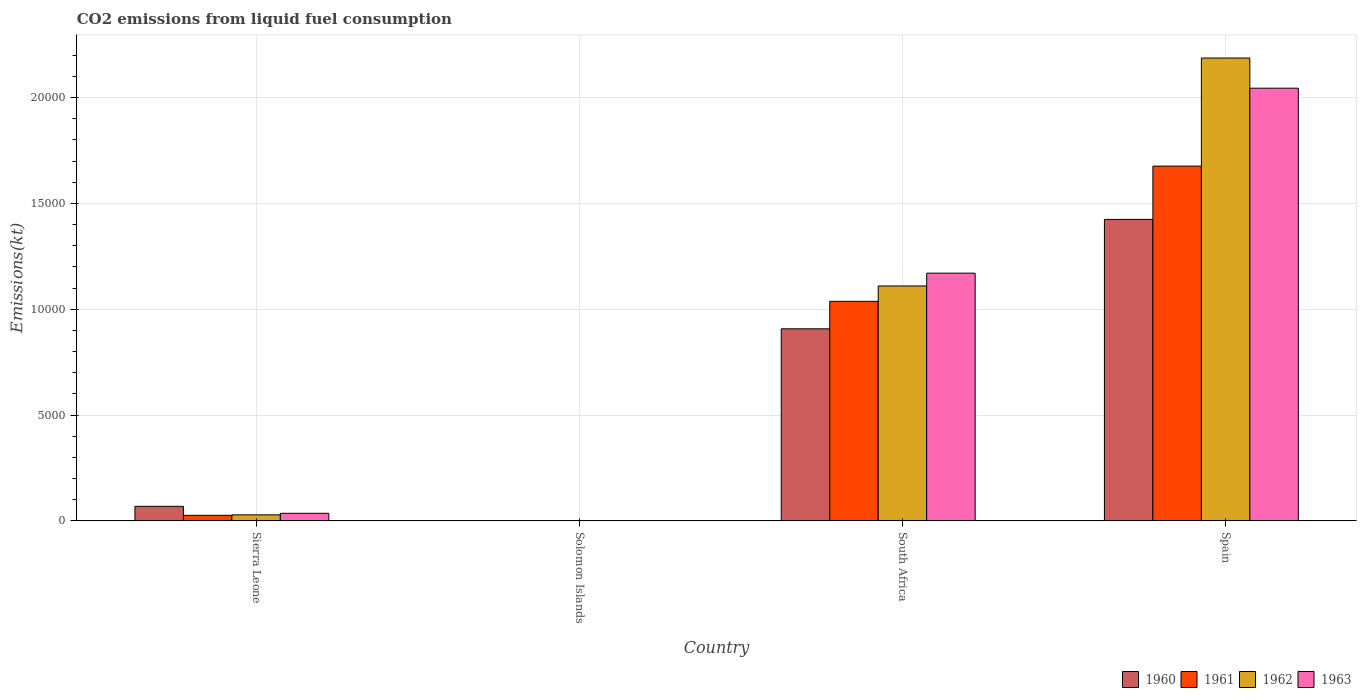Are the number of bars per tick equal to the number of legend labels?
Offer a very short reply. Yes. Are the number of bars on each tick of the X-axis equal?
Your answer should be very brief. Yes. How many bars are there on the 2nd tick from the left?
Offer a very short reply. 4. In how many cases, is the number of bars for a given country not equal to the number of legend labels?
Offer a very short reply. 0. What is the amount of CO2 emitted in 1962 in South Africa?
Provide a succinct answer. 1.11e+04. Across all countries, what is the maximum amount of CO2 emitted in 1962?
Provide a short and direct response. 2.19e+04. Across all countries, what is the minimum amount of CO2 emitted in 1962?
Give a very brief answer. 14.67. In which country was the amount of CO2 emitted in 1960 maximum?
Your answer should be compact. Spain. In which country was the amount of CO2 emitted in 1961 minimum?
Keep it short and to the point. Solomon Islands. What is the total amount of CO2 emitted in 1960 in the graph?
Ensure brevity in your answer.  2.40e+04. What is the difference between the amount of CO2 emitted in 1961 in South Africa and that in Spain?
Your answer should be compact. -6391.58. What is the difference between the amount of CO2 emitted in 1960 in Solomon Islands and the amount of CO2 emitted in 1962 in Sierra Leone?
Your response must be concise. -271.36. What is the average amount of CO2 emitted in 1963 per country?
Your answer should be very brief. 8130.66. What is the difference between the amount of CO2 emitted of/in 1961 and amount of CO2 emitted of/in 1962 in South Africa?
Offer a terse response. -726.07. What is the ratio of the amount of CO2 emitted in 1962 in Sierra Leone to that in Spain?
Provide a short and direct response. 0.01. Is the amount of CO2 emitted in 1962 in Solomon Islands less than that in Spain?
Offer a very short reply. Yes. What is the difference between the highest and the second highest amount of CO2 emitted in 1962?
Your response must be concise. 2.16e+04. What is the difference between the highest and the lowest amount of CO2 emitted in 1961?
Your answer should be compact. 1.68e+04. What does the 1st bar from the right in South Africa represents?
Provide a short and direct response. 1963. Is it the case that in every country, the sum of the amount of CO2 emitted in 1963 and amount of CO2 emitted in 1960 is greater than the amount of CO2 emitted in 1961?
Ensure brevity in your answer.  Yes. What is the difference between two consecutive major ticks on the Y-axis?
Ensure brevity in your answer.  5000. Does the graph contain any zero values?
Provide a succinct answer. No. Where does the legend appear in the graph?
Keep it short and to the point. Bottom right. How many legend labels are there?
Make the answer very short. 4. What is the title of the graph?
Your answer should be compact. CO2 emissions from liquid fuel consumption. What is the label or title of the X-axis?
Provide a short and direct response. Country. What is the label or title of the Y-axis?
Offer a very short reply. Emissions(kt). What is the Emissions(kt) in 1960 in Sierra Leone?
Your answer should be compact. 685.73. What is the Emissions(kt) of 1961 in Sierra Leone?
Keep it short and to the point. 260.36. What is the Emissions(kt) in 1962 in Sierra Leone?
Ensure brevity in your answer.  282.36. What is the Emissions(kt) of 1963 in Sierra Leone?
Make the answer very short. 355.7. What is the Emissions(kt) of 1960 in Solomon Islands?
Make the answer very short. 11. What is the Emissions(kt) in 1961 in Solomon Islands?
Ensure brevity in your answer.  14.67. What is the Emissions(kt) in 1962 in Solomon Islands?
Keep it short and to the point. 14.67. What is the Emissions(kt) of 1963 in Solomon Islands?
Offer a very short reply. 14.67. What is the Emissions(kt) of 1960 in South Africa?
Provide a succinct answer. 9075.83. What is the Emissions(kt) of 1961 in South Africa?
Provide a succinct answer. 1.04e+04. What is the Emissions(kt) of 1962 in South Africa?
Your answer should be very brief. 1.11e+04. What is the Emissions(kt) of 1963 in South Africa?
Provide a succinct answer. 1.17e+04. What is the Emissions(kt) in 1960 in Spain?
Your response must be concise. 1.42e+04. What is the Emissions(kt) of 1961 in Spain?
Make the answer very short. 1.68e+04. What is the Emissions(kt) of 1962 in Spain?
Keep it short and to the point. 2.19e+04. What is the Emissions(kt) in 1963 in Spain?
Your answer should be very brief. 2.04e+04. Across all countries, what is the maximum Emissions(kt) of 1960?
Ensure brevity in your answer.  1.42e+04. Across all countries, what is the maximum Emissions(kt) of 1961?
Give a very brief answer. 1.68e+04. Across all countries, what is the maximum Emissions(kt) in 1962?
Your answer should be very brief. 2.19e+04. Across all countries, what is the maximum Emissions(kt) in 1963?
Offer a terse response. 2.04e+04. Across all countries, what is the minimum Emissions(kt) in 1960?
Your response must be concise. 11. Across all countries, what is the minimum Emissions(kt) in 1961?
Your answer should be very brief. 14.67. Across all countries, what is the minimum Emissions(kt) in 1962?
Your response must be concise. 14.67. Across all countries, what is the minimum Emissions(kt) of 1963?
Ensure brevity in your answer.  14.67. What is the total Emissions(kt) in 1960 in the graph?
Your answer should be very brief. 2.40e+04. What is the total Emissions(kt) of 1961 in the graph?
Offer a very short reply. 2.74e+04. What is the total Emissions(kt) of 1962 in the graph?
Keep it short and to the point. 3.33e+04. What is the total Emissions(kt) of 1963 in the graph?
Ensure brevity in your answer.  3.25e+04. What is the difference between the Emissions(kt) of 1960 in Sierra Leone and that in Solomon Islands?
Offer a very short reply. 674.73. What is the difference between the Emissions(kt) in 1961 in Sierra Leone and that in Solomon Islands?
Your response must be concise. 245.69. What is the difference between the Emissions(kt) of 1962 in Sierra Leone and that in Solomon Islands?
Provide a succinct answer. 267.69. What is the difference between the Emissions(kt) in 1963 in Sierra Leone and that in Solomon Islands?
Keep it short and to the point. 341.03. What is the difference between the Emissions(kt) of 1960 in Sierra Leone and that in South Africa?
Offer a terse response. -8390.1. What is the difference between the Emissions(kt) in 1961 in Sierra Leone and that in South Africa?
Provide a succinct answer. -1.01e+04. What is the difference between the Emissions(kt) in 1962 in Sierra Leone and that in South Africa?
Provide a succinct answer. -1.08e+04. What is the difference between the Emissions(kt) of 1963 in Sierra Leone and that in South Africa?
Offer a very short reply. -1.13e+04. What is the difference between the Emissions(kt) of 1960 in Sierra Leone and that in Spain?
Give a very brief answer. -1.36e+04. What is the difference between the Emissions(kt) in 1961 in Sierra Leone and that in Spain?
Ensure brevity in your answer.  -1.65e+04. What is the difference between the Emissions(kt) in 1962 in Sierra Leone and that in Spain?
Make the answer very short. -2.16e+04. What is the difference between the Emissions(kt) of 1963 in Sierra Leone and that in Spain?
Make the answer very short. -2.01e+04. What is the difference between the Emissions(kt) of 1960 in Solomon Islands and that in South Africa?
Offer a very short reply. -9064.82. What is the difference between the Emissions(kt) of 1961 in Solomon Islands and that in South Africa?
Keep it short and to the point. -1.04e+04. What is the difference between the Emissions(kt) in 1962 in Solomon Islands and that in South Africa?
Provide a short and direct response. -1.11e+04. What is the difference between the Emissions(kt) in 1963 in Solomon Islands and that in South Africa?
Give a very brief answer. -1.17e+04. What is the difference between the Emissions(kt) of 1960 in Solomon Islands and that in Spain?
Make the answer very short. -1.42e+04. What is the difference between the Emissions(kt) of 1961 in Solomon Islands and that in Spain?
Ensure brevity in your answer.  -1.68e+04. What is the difference between the Emissions(kt) in 1962 in Solomon Islands and that in Spain?
Offer a terse response. -2.19e+04. What is the difference between the Emissions(kt) of 1963 in Solomon Islands and that in Spain?
Provide a short and direct response. -2.04e+04. What is the difference between the Emissions(kt) in 1960 in South Africa and that in Spain?
Your answer should be very brief. -5170.47. What is the difference between the Emissions(kt) in 1961 in South Africa and that in Spain?
Your answer should be compact. -6391.58. What is the difference between the Emissions(kt) in 1962 in South Africa and that in Spain?
Keep it short and to the point. -1.08e+04. What is the difference between the Emissions(kt) of 1963 in South Africa and that in Spain?
Offer a terse response. -8742.13. What is the difference between the Emissions(kt) of 1960 in Sierra Leone and the Emissions(kt) of 1961 in Solomon Islands?
Make the answer very short. 671.06. What is the difference between the Emissions(kt) of 1960 in Sierra Leone and the Emissions(kt) of 1962 in Solomon Islands?
Provide a succinct answer. 671.06. What is the difference between the Emissions(kt) of 1960 in Sierra Leone and the Emissions(kt) of 1963 in Solomon Islands?
Offer a terse response. 671.06. What is the difference between the Emissions(kt) of 1961 in Sierra Leone and the Emissions(kt) of 1962 in Solomon Islands?
Your response must be concise. 245.69. What is the difference between the Emissions(kt) of 1961 in Sierra Leone and the Emissions(kt) of 1963 in Solomon Islands?
Your answer should be very brief. 245.69. What is the difference between the Emissions(kt) of 1962 in Sierra Leone and the Emissions(kt) of 1963 in Solomon Islands?
Provide a succinct answer. 267.69. What is the difference between the Emissions(kt) in 1960 in Sierra Leone and the Emissions(kt) in 1961 in South Africa?
Your response must be concise. -9688.21. What is the difference between the Emissions(kt) of 1960 in Sierra Leone and the Emissions(kt) of 1962 in South Africa?
Keep it short and to the point. -1.04e+04. What is the difference between the Emissions(kt) of 1960 in Sierra Leone and the Emissions(kt) of 1963 in South Africa?
Give a very brief answer. -1.10e+04. What is the difference between the Emissions(kt) in 1961 in Sierra Leone and the Emissions(kt) in 1962 in South Africa?
Your answer should be very brief. -1.08e+04. What is the difference between the Emissions(kt) in 1961 in Sierra Leone and the Emissions(kt) in 1963 in South Africa?
Offer a terse response. -1.14e+04. What is the difference between the Emissions(kt) of 1962 in Sierra Leone and the Emissions(kt) of 1963 in South Africa?
Offer a terse response. -1.14e+04. What is the difference between the Emissions(kt) of 1960 in Sierra Leone and the Emissions(kt) of 1961 in Spain?
Ensure brevity in your answer.  -1.61e+04. What is the difference between the Emissions(kt) of 1960 in Sierra Leone and the Emissions(kt) of 1962 in Spain?
Make the answer very short. -2.12e+04. What is the difference between the Emissions(kt) in 1960 in Sierra Leone and the Emissions(kt) in 1963 in Spain?
Offer a terse response. -1.98e+04. What is the difference between the Emissions(kt) of 1961 in Sierra Leone and the Emissions(kt) of 1962 in Spain?
Your response must be concise. -2.16e+04. What is the difference between the Emissions(kt) in 1961 in Sierra Leone and the Emissions(kt) in 1963 in Spain?
Offer a terse response. -2.02e+04. What is the difference between the Emissions(kt) of 1962 in Sierra Leone and the Emissions(kt) of 1963 in Spain?
Your response must be concise. -2.02e+04. What is the difference between the Emissions(kt) of 1960 in Solomon Islands and the Emissions(kt) of 1961 in South Africa?
Keep it short and to the point. -1.04e+04. What is the difference between the Emissions(kt) in 1960 in Solomon Islands and the Emissions(kt) in 1962 in South Africa?
Offer a terse response. -1.11e+04. What is the difference between the Emissions(kt) of 1960 in Solomon Islands and the Emissions(kt) of 1963 in South Africa?
Offer a very short reply. -1.17e+04. What is the difference between the Emissions(kt) in 1961 in Solomon Islands and the Emissions(kt) in 1962 in South Africa?
Keep it short and to the point. -1.11e+04. What is the difference between the Emissions(kt) of 1961 in Solomon Islands and the Emissions(kt) of 1963 in South Africa?
Your answer should be compact. -1.17e+04. What is the difference between the Emissions(kt) of 1962 in Solomon Islands and the Emissions(kt) of 1963 in South Africa?
Keep it short and to the point. -1.17e+04. What is the difference between the Emissions(kt) in 1960 in Solomon Islands and the Emissions(kt) in 1961 in Spain?
Your answer should be very brief. -1.68e+04. What is the difference between the Emissions(kt) in 1960 in Solomon Islands and the Emissions(kt) in 1962 in Spain?
Provide a short and direct response. -2.19e+04. What is the difference between the Emissions(kt) in 1960 in Solomon Islands and the Emissions(kt) in 1963 in Spain?
Ensure brevity in your answer.  -2.04e+04. What is the difference between the Emissions(kt) of 1961 in Solomon Islands and the Emissions(kt) of 1962 in Spain?
Your answer should be compact. -2.19e+04. What is the difference between the Emissions(kt) in 1961 in Solomon Islands and the Emissions(kt) in 1963 in Spain?
Your answer should be very brief. -2.04e+04. What is the difference between the Emissions(kt) in 1962 in Solomon Islands and the Emissions(kt) in 1963 in Spain?
Provide a succinct answer. -2.04e+04. What is the difference between the Emissions(kt) in 1960 in South Africa and the Emissions(kt) in 1961 in Spain?
Keep it short and to the point. -7689.7. What is the difference between the Emissions(kt) in 1960 in South Africa and the Emissions(kt) in 1962 in Spain?
Ensure brevity in your answer.  -1.28e+04. What is the difference between the Emissions(kt) of 1960 in South Africa and the Emissions(kt) of 1963 in Spain?
Offer a very short reply. -1.14e+04. What is the difference between the Emissions(kt) of 1961 in South Africa and the Emissions(kt) of 1962 in Spain?
Offer a very short reply. -1.15e+04. What is the difference between the Emissions(kt) in 1961 in South Africa and the Emissions(kt) in 1963 in Spain?
Your answer should be very brief. -1.01e+04. What is the difference between the Emissions(kt) in 1962 in South Africa and the Emissions(kt) in 1963 in Spain?
Provide a succinct answer. -9347.18. What is the average Emissions(kt) of 1960 per country?
Make the answer very short. 6004.71. What is the average Emissions(kt) in 1961 per country?
Make the answer very short. 6853.62. What is the average Emissions(kt) of 1962 per country?
Make the answer very short. 8317.67. What is the average Emissions(kt) in 1963 per country?
Your answer should be compact. 8130.66. What is the difference between the Emissions(kt) of 1960 and Emissions(kt) of 1961 in Sierra Leone?
Provide a succinct answer. 425.37. What is the difference between the Emissions(kt) of 1960 and Emissions(kt) of 1962 in Sierra Leone?
Offer a very short reply. 403.37. What is the difference between the Emissions(kt) of 1960 and Emissions(kt) of 1963 in Sierra Leone?
Your response must be concise. 330.03. What is the difference between the Emissions(kt) of 1961 and Emissions(kt) of 1962 in Sierra Leone?
Make the answer very short. -22. What is the difference between the Emissions(kt) of 1961 and Emissions(kt) of 1963 in Sierra Leone?
Your answer should be compact. -95.34. What is the difference between the Emissions(kt) in 1962 and Emissions(kt) in 1963 in Sierra Leone?
Ensure brevity in your answer.  -73.34. What is the difference between the Emissions(kt) in 1960 and Emissions(kt) in 1961 in Solomon Islands?
Ensure brevity in your answer.  -3.67. What is the difference between the Emissions(kt) of 1960 and Emissions(kt) of 1962 in Solomon Islands?
Make the answer very short. -3.67. What is the difference between the Emissions(kt) of 1960 and Emissions(kt) of 1963 in Solomon Islands?
Provide a short and direct response. -3.67. What is the difference between the Emissions(kt) in 1961 and Emissions(kt) in 1962 in Solomon Islands?
Give a very brief answer. 0. What is the difference between the Emissions(kt) in 1960 and Emissions(kt) in 1961 in South Africa?
Provide a succinct answer. -1298.12. What is the difference between the Emissions(kt) of 1960 and Emissions(kt) of 1962 in South Africa?
Your answer should be very brief. -2024.18. What is the difference between the Emissions(kt) of 1960 and Emissions(kt) of 1963 in South Africa?
Provide a succinct answer. -2629.24. What is the difference between the Emissions(kt) of 1961 and Emissions(kt) of 1962 in South Africa?
Keep it short and to the point. -726.07. What is the difference between the Emissions(kt) in 1961 and Emissions(kt) in 1963 in South Africa?
Your response must be concise. -1331.12. What is the difference between the Emissions(kt) of 1962 and Emissions(kt) of 1963 in South Africa?
Ensure brevity in your answer.  -605.05. What is the difference between the Emissions(kt) of 1960 and Emissions(kt) of 1961 in Spain?
Keep it short and to the point. -2519.23. What is the difference between the Emissions(kt) of 1960 and Emissions(kt) of 1962 in Spain?
Your answer should be compact. -7627.36. What is the difference between the Emissions(kt) of 1960 and Emissions(kt) of 1963 in Spain?
Offer a very short reply. -6200.9. What is the difference between the Emissions(kt) in 1961 and Emissions(kt) in 1962 in Spain?
Offer a very short reply. -5108.13. What is the difference between the Emissions(kt) in 1961 and Emissions(kt) in 1963 in Spain?
Keep it short and to the point. -3681.67. What is the difference between the Emissions(kt) of 1962 and Emissions(kt) of 1963 in Spain?
Provide a short and direct response. 1426.46. What is the ratio of the Emissions(kt) in 1960 in Sierra Leone to that in Solomon Islands?
Your response must be concise. 62.33. What is the ratio of the Emissions(kt) in 1961 in Sierra Leone to that in Solomon Islands?
Provide a short and direct response. 17.75. What is the ratio of the Emissions(kt) in 1962 in Sierra Leone to that in Solomon Islands?
Make the answer very short. 19.25. What is the ratio of the Emissions(kt) in 1963 in Sierra Leone to that in Solomon Islands?
Provide a short and direct response. 24.25. What is the ratio of the Emissions(kt) in 1960 in Sierra Leone to that in South Africa?
Give a very brief answer. 0.08. What is the ratio of the Emissions(kt) of 1961 in Sierra Leone to that in South Africa?
Your answer should be very brief. 0.03. What is the ratio of the Emissions(kt) in 1962 in Sierra Leone to that in South Africa?
Your answer should be very brief. 0.03. What is the ratio of the Emissions(kt) in 1963 in Sierra Leone to that in South Africa?
Provide a succinct answer. 0.03. What is the ratio of the Emissions(kt) of 1960 in Sierra Leone to that in Spain?
Ensure brevity in your answer.  0.05. What is the ratio of the Emissions(kt) in 1961 in Sierra Leone to that in Spain?
Your answer should be very brief. 0.02. What is the ratio of the Emissions(kt) in 1962 in Sierra Leone to that in Spain?
Keep it short and to the point. 0.01. What is the ratio of the Emissions(kt) in 1963 in Sierra Leone to that in Spain?
Ensure brevity in your answer.  0.02. What is the ratio of the Emissions(kt) in 1960 in Solomon Islands to that in South Africa?
Your answer should be very brief. 0. What is the ratio of the Emissions(kt) in 1961 in Solomon Islands to that in South Africa?
Provide a succinct answer. 0. What is the ratio of the Emissions(kt) of 1962 in Solomon Islands to that in South Africa?
Your answer should be compact. 0. What is the ratio of the Emissions(kt) of 1963 in Solomon Islands to that in South Africa?
Make the answer very short. 0. What is the ratio of the Emissions(kt) in 1960 in Solomon Islands to that in Spain?
Your answer should be very brief. 0. What is the ratio of the Emissions(kt) in 1961 in Solomon Islands to that in Spain?
Provide a short and direct response. 0. What is the ratio of the Emissions(kt) of 1962 in Solomon Islands to that in Spain?
Make the answer very short. 0. What is the ratio of the Emissions(kt) in 1963 in Solomon Islands to that in Spain?
Offer a terse response. 0. What is the ratio of the Emissions(kt) in 1960 in South Africa to that in Spain?
Your answer should be compact. 0.64. What is the ratio of the Emissions(kt) of 1961 in South Africa to that in Spain?
Your answer should be compact. 0.62. What is the ratio of the Emissions(kt) of 1962 in South Africa to that in Spain?
Provide a succinct answer. 0.51. What is the ratio of the Emissions(kt) of 1963 in South Africa to that in Spain?
Provide a succinct answer. 0.57. What is the difference between the highest and the second highest Emissions(kt) of 1960?
Offer a terse response. 5170.47. What is the difference between the highest and the second highest Emissions(kt) of 1961?
Offer a very short reply. 6391.58. What is the difference between the highest and the second highest Emissions(kt) of 1962?
Your response must be concise. 1.08e+04. What is the difference between the highest and the second highest Emissions(kt) of 1963?
Keep it short and to the point. 8742.13. What is the difference between the highest and the lowest Emissions(kt) of 1960?
Offer a very short reply. 1.42e+04. What is the difference between the highest and the lowest Emissions(kt) of 1961?
Your response must be concise. 1.68e+04. What is the difference between the highest and the lowest Emissions(kt) in 1962?
Make the answer very short. 2.19e+04. What is the difference between the highest and the lowest Emissions(kt) in 1963?
Keep it short and to the point. 2.04e+04. 